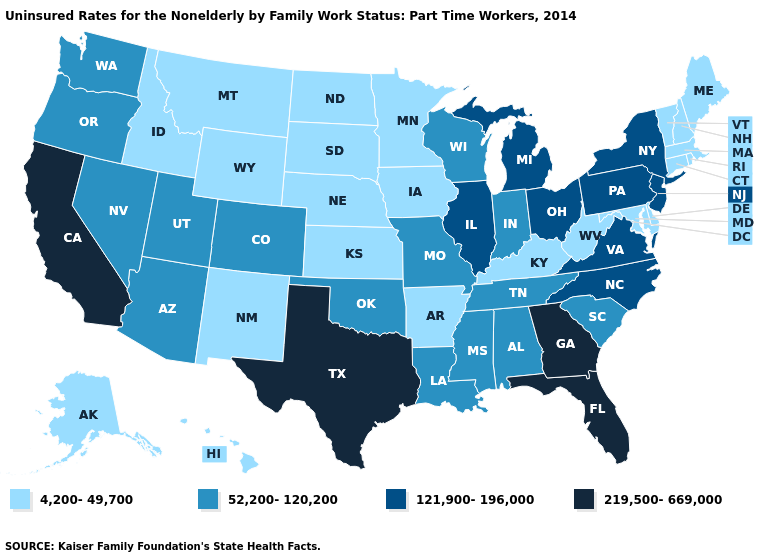Among the states that border Indiana , does Ohio have the highest value?
Keep it brief. Yes. Name the states that have a value in the range 4,200-49,700?
Be succinct. Alaska, Arkansas, Connecticut, Delaware, Hawaii, Idaho, Iowa, Kansas, Kentucky, Maine, Maryland, Massachusetts, Minnesota, Montana, Nebraska, New Hampshire, New Mexico, North Dakota, Rhode Island, South Dakota, Vermont, West Virginia, Wyoming. Does Alabama have the highest value in the South?
Short answer required. No. Which states have the lowest value in the South?
Be succinct. Arkansas, Delaware, Kentucky, Maryland, West Virginia. Which states have the lowest value in the USA?
Be succinct. Alaska, Arkansas, Connecticut, Delaware, Hawaii, Idaho, Iowa, Kansas, Kentucky, Maine, Maryland, Massachusetts, Minnesota, Montana, Nebraska, New Hampshire, New Mexico, North Dakota, Rhode Island, South Dakota, Vermont, West Virginia, Wyoming. What is the value of Ohio?
Answer briefly. 121,900-196,000. What is the value of Washington?
Answer briefly. 52,200-120,200. Does the map have missing data?
Write a very short answer. No. Name the states that have a value in the range 219,500-669,000?
Quick response, please. California, Florida, Georgia, Texas. What is the value of South Dakota?
Answer briefly. 4,200-49,700. Does Maryland have the lowest value in the South?
Answer briefly. Yes. Does Rhode Island have the lowest value in the USA?
Concise answer only. Yes. Name the states that have a value in the range 52,200-120,200?
Concise answer only. Alabama, Arizona, Colorado, Indiana, Louisiana, Mississippi, Missouri, Nevada, Oklahoma, Oregon, South Carolina, Tennessee, Utah, Washington, Wisconsin. What is the value of New Mexico?
Be succinct. 4,200-49,700. What is the lowest value in the USA?
Concise answer only. 4,200-49,700. 